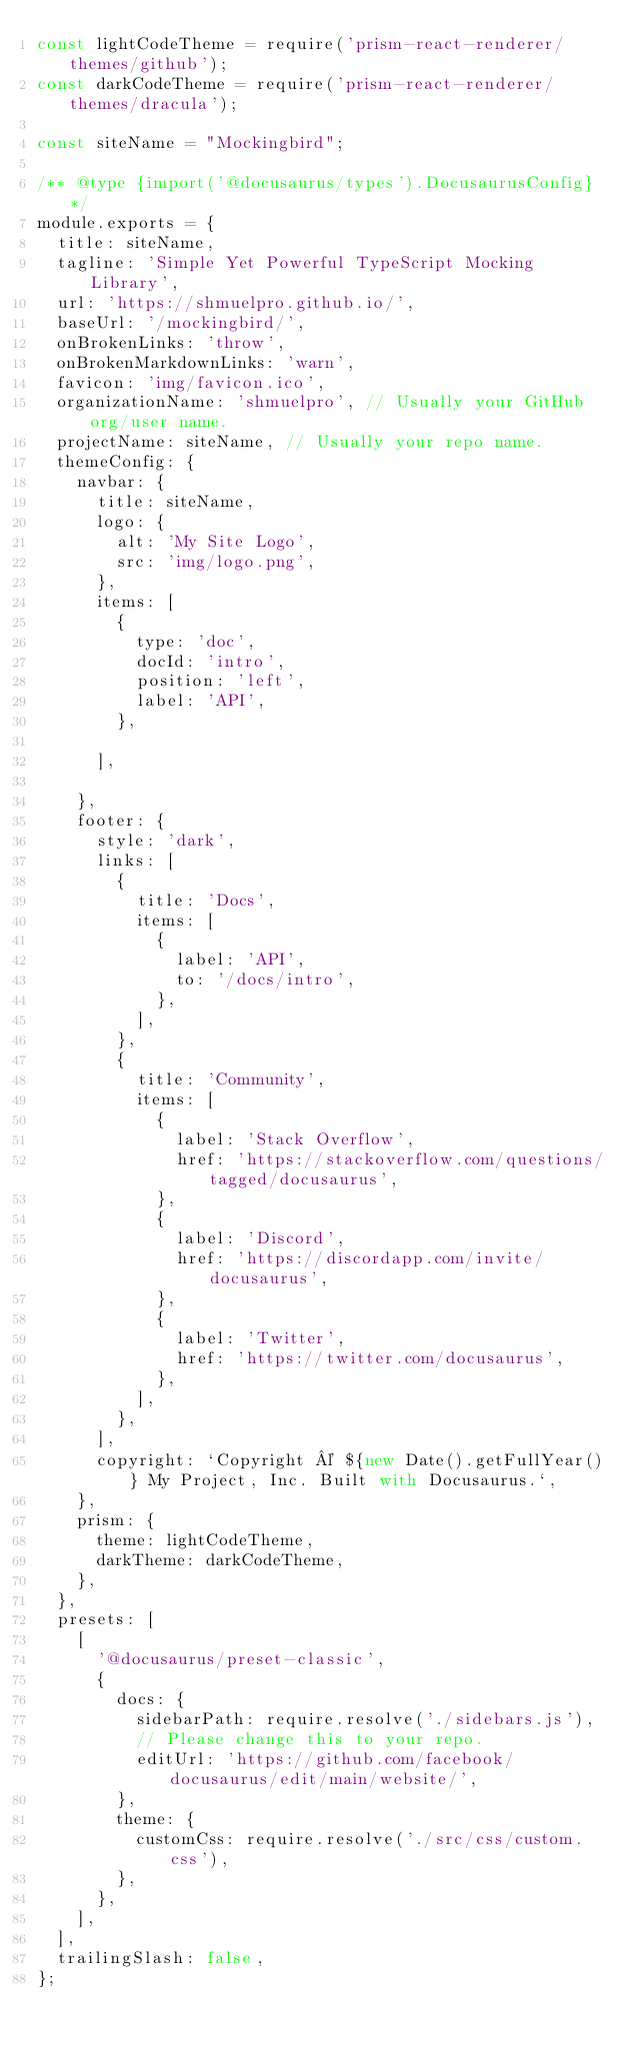Convert code to text. <code><loc_0><loc_0><loc_500><loc_500><_JavaScript_>const lightCodeTheme = require('prism-react-renderer/themes/github');
const darkCodeTheme = require('prism-react-renderer/themes/dracula');

const siteName = "Mockingbird";

/** @type {import('@docusaurus/types').DocusaurusConfig} */
module.exports = {
  title: siteName,  
  tagline: 'Simple Yet Powerful TypeScript Mocking Library',
  url: 'https://shmuelpro.github.io/',
  baseUrl: '/mockingbird/',
  onBrokenLinks: 'throw',
  onBrokenMarkdownLinks: 'warn',
  favicon: 'img/favicon.ico',
  organizationName: 'shmuelpro', // Usually your GitHub org/user name.
  projectName: siteName, // Usually your repo name.
  themeConfig: {
    navbar: {
      title: siteName,
      logo: {
        alt: 'My Site Logo',
        src: 'img/logo.png',
      },
      items: [
        {
          type: 'doc',
          docId: 'intro',
          position: 'left',
          label: 'API',
        },       
        
      ],
      
    },
    footer: {
      style: 'dark',
      links: [
        {
          title: 'Docs',
          items: [
            {
              label: 'API',
              to: '/docs/intro',
            },
          ],
        },
        {
          title: 'Community',
          items: [
            {
              label: 'Stack Overflow',
              href: 'https://stackoverflow.com/questions/tagged/docusaurus',
            },
            {
              label: 'Discord',
              href: 'https://discordapp.com/invite/docusaurus',
            },
            {
              label: 'Twitter',
              href: 'https://twitter.com/docusaurus',
            },
          ],
        },       
      ],
      copyright: `Copyright © ${new Date().getFullYear()} My Project, Inc. Built with Docusaurus.`,
    },
    prism: {
      theme: lightCodeTheme,
      darkTheme: darkCodeTheme,
    },
  },
  presets: [
    [
      '@docusaurus/preset-classic',
      {
        docs: {
          sidebarPath: require.resolve('./sidebars.js'),
          // Please change this to your repo.
          editUrl: 'https://github.com/facebook/docusaurus/edit/main/website/',
        },       
        theme: {
          customCss: require.resolve('./src/css/custom.css'),
        },
      },
    ],
  ],
  trailingSlash: false,
};
</code> 